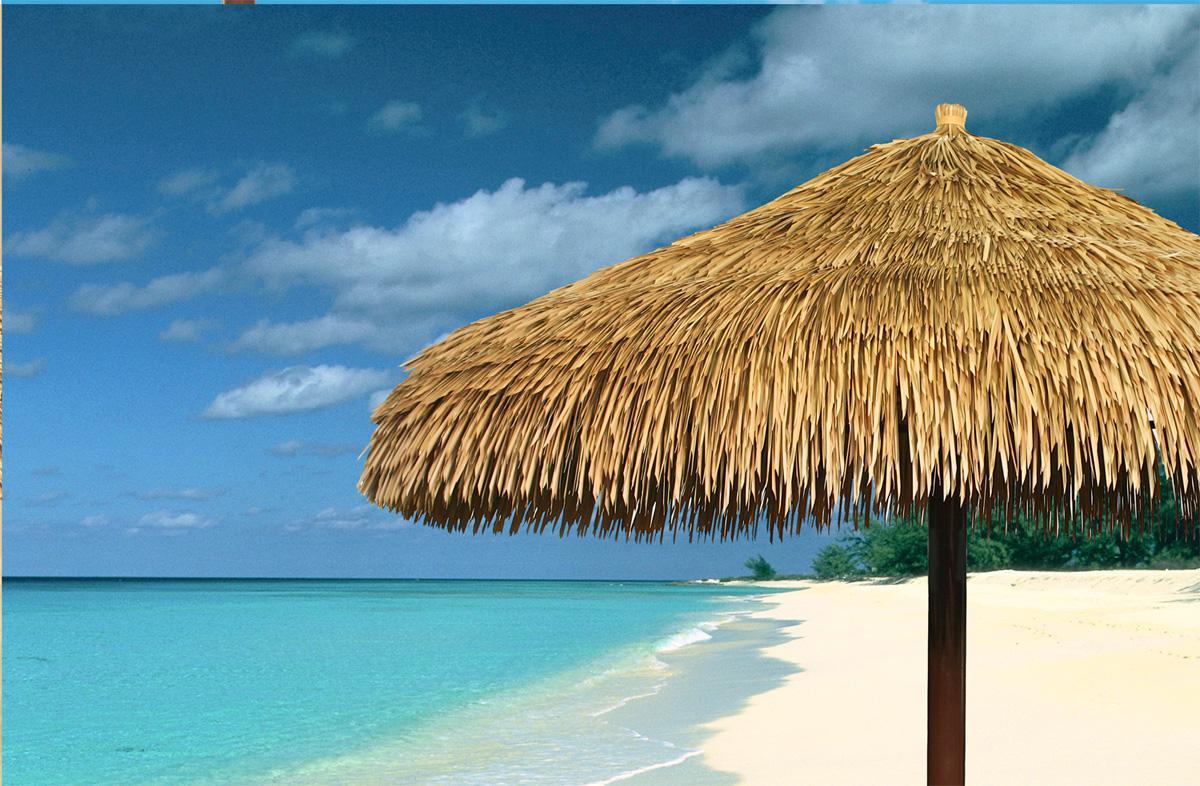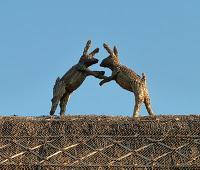The first image is the image on the left, the second image is the image on the right. Analyze the images presented: Is the assertion "At least one animal is standing on the roof in the image on the right." valid? Answer yes or no. Yes. The first image is the image on the left, the second image is the image on the right. Examine the images to the left and right. Is the description "The left image features a simple peaked thatch roof with a small projection at the top, and the right image features at least one animal figure on the edge of a peaked roof with diamond 'stitched' border." accurate? Answer yes or no. Yes. 